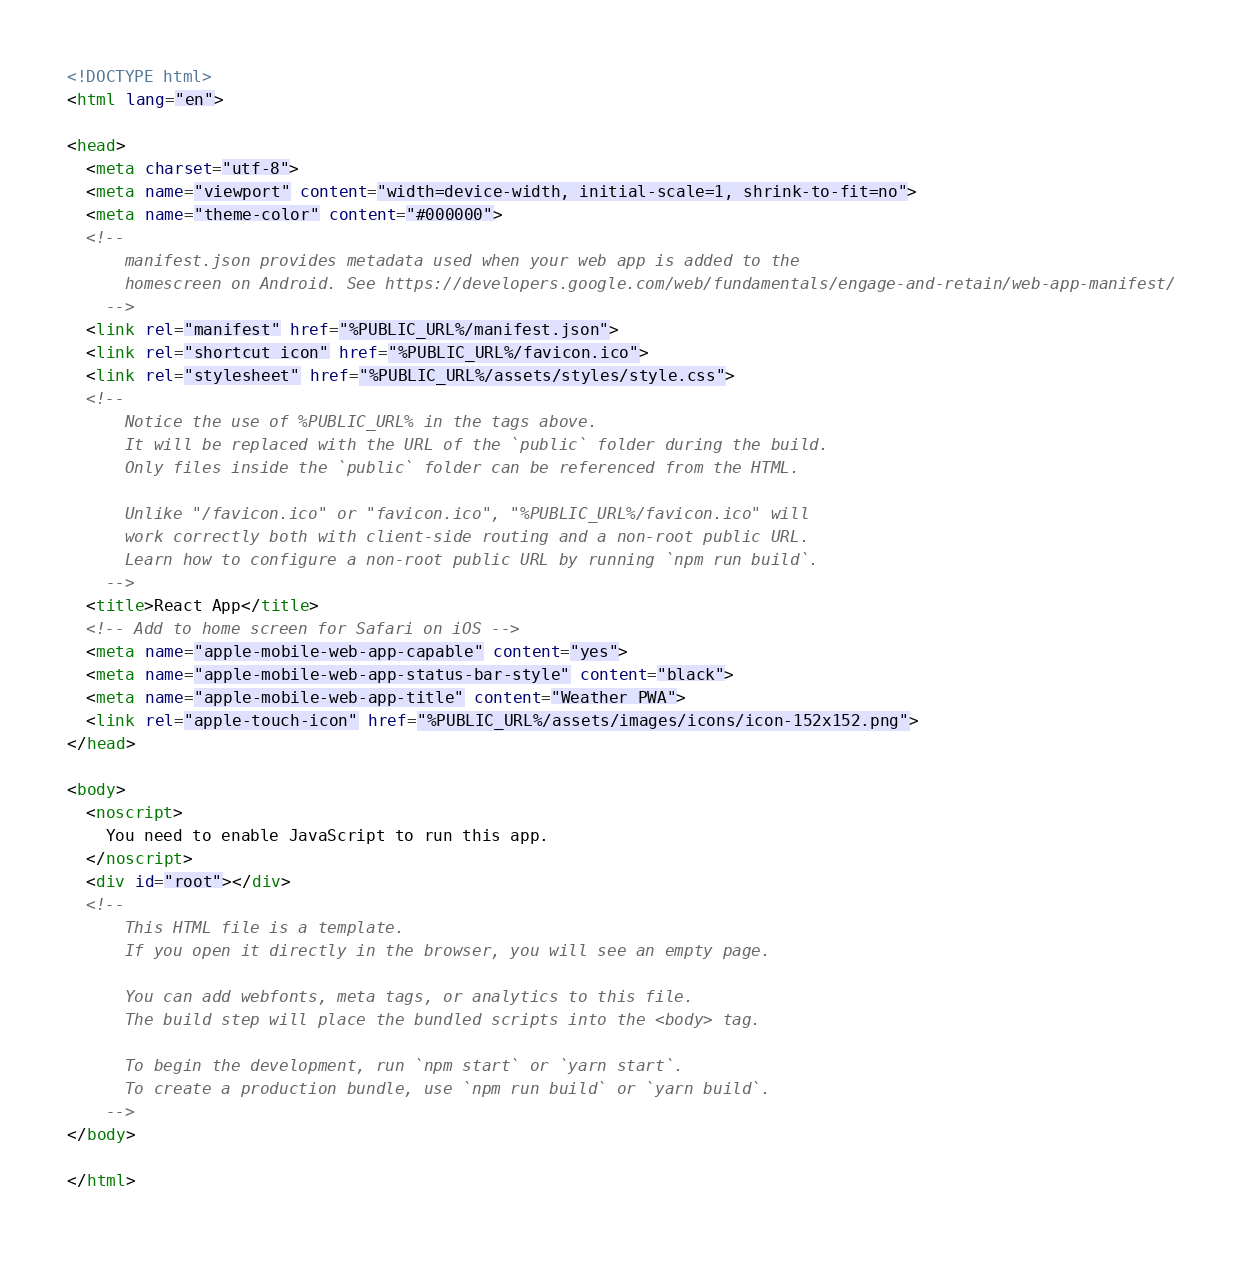Convert code to text. <code><loc_0><loc_0><loc_500><loc_500><_HTML_><!DOCTYPE html>
<html lang="en">

<head>
  <meta charset="utf-8">
  <meta name="viewport" content="width=device-width, initial-scale=1, shrink-to-fit=no">
  <meta name="theme-color" content="#000000">
  <!--
      manifest.json provides metadata used when your web app is added to the
      homescreen on Android. See https://developers.google.com/web/fundamentals/engage-and-retain/web-app-manifest/
    -->
  <link rel="manifest" href="%PUBLIC_URL%/manifest.json">
  <link rel="shortcut icon" href="%PUBLIC_URL%/favicon.ico">
  <link rel="stylesheet" href="%PUBLIC_URL%/assets/styles/style.css">
  <!--
      Notice the use of %PUBLIC_URL% in the tags above.
      It will be replaced with the URL of the `public` folder during the build.
      Only files inside the `public` folder can be referenced from the HTML.

      Unlike "/favicon.ico" or "favicon.ico", "%PUBLIC_URL%/favicon.ico" will
      work correctly both with client-side routing and a non-root public URL.
      Learn how to configure a non-root public URL by running `npm run build`.
    -->
  <title>React App</title>
  <!-- Add to home screen for Safari on iOS -->
  <meta name="apple-mobile-web-app-capable" content="yes">
  <meta name="apple-mobile-web-app-status-bar-style" content="black">
  <meta name="apple-mobile-web-app-title" content="Weather PWA">
  <link rel="apple-touch-icon" href="%PUBLIC_URL%/assets/images/icons/icon-152x152.png">
</head>

<body>
  <noscript>
    You need to enable JavaScript to run this app.
  </noscript>
  <div id="root"></div>
  <!--
      This HTML file is a template.
      If you open it directly in the browser, you will see an empty page.

      You can add webfonts, meta tags, or analytics to this file.
      The build step will place the bundled scripts into the <body> tag.

      To begin the development, run `npm start` or `yarn start`.
      To create a production bundle, use `npm run build` or `yarn build`.
    -->
</body>

</html></code> 